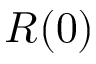Convert formula to latex. <formula><loc_0><loc_0><loc_500><loc_500>R ( 0 )</formula> 